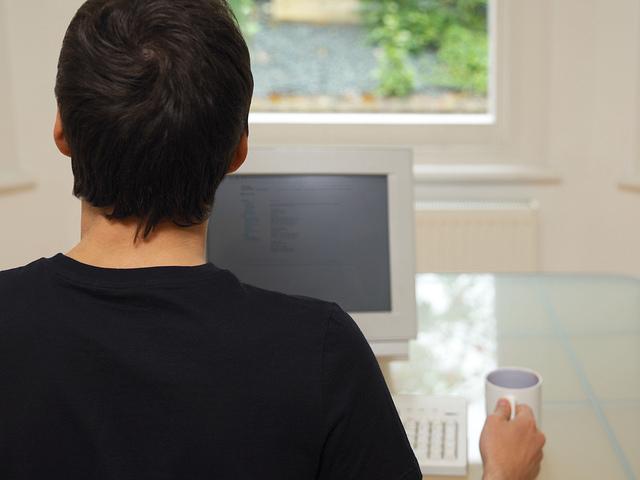How many windows are there?
Concise answer only. 1. How many people are in the photo?
Write a very short answer. 1. Is that a new computer?
Keep it brief. No. Is the person in the picture older than 50?
Write a very short answer. No. What color is the computer in this picture?
Write a very short answer. White. 